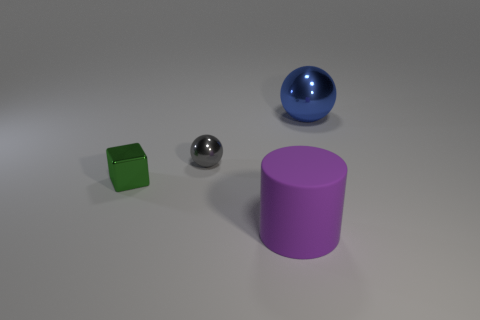Add 3 big things. How many objects exist? 7 Subtract all cylinders. How many objects are left? 3 Subtract 0 red blocks. How many objects are left? 4 Subtract all tiny gray metallic spheres. Subtract all large objects. How many objects are left? 1 Add 2 large purple matte objects. How many large purple matte objects are left? 3 Add 3 large things. How many large things exist? 5 